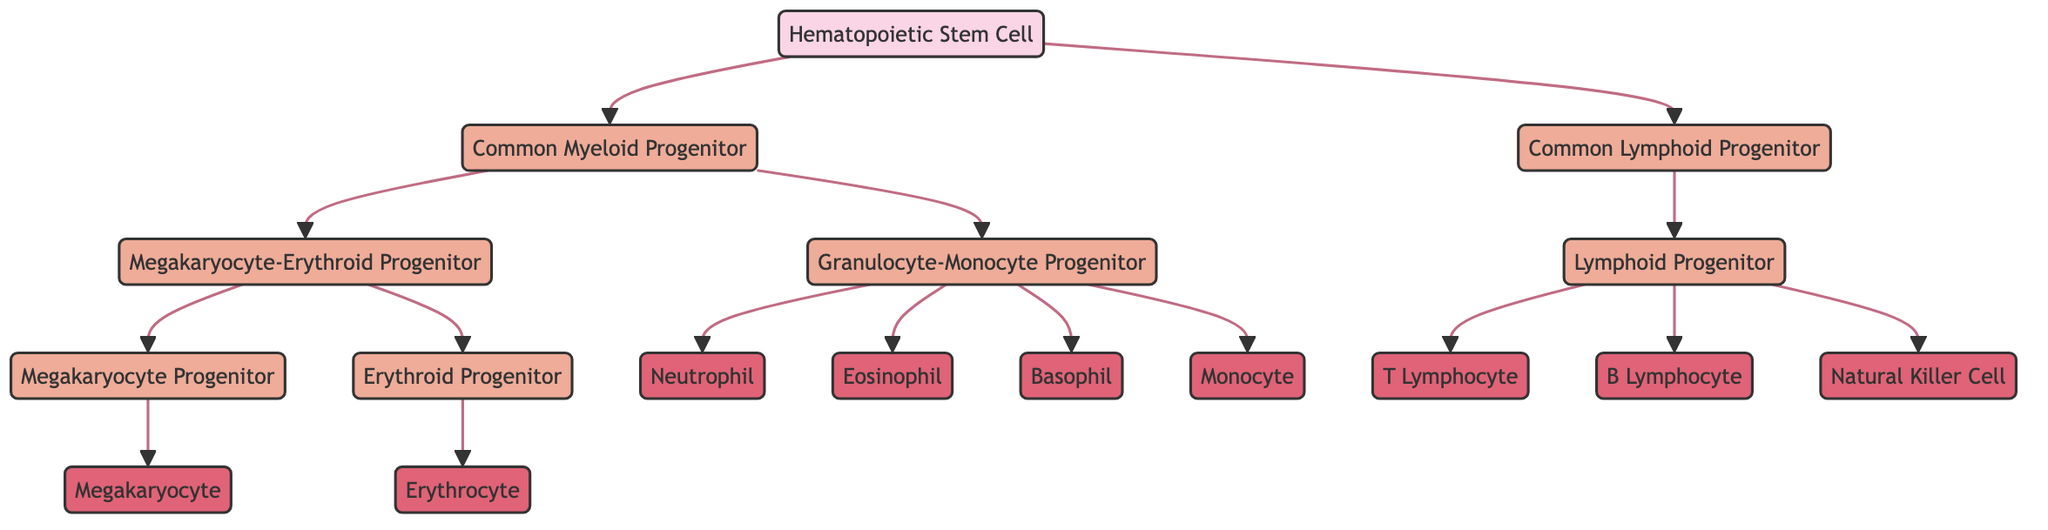What is the root node in this diagram? The root node, or the starting point of the hierarchy, is the Hematopoietic Stem Cell (HSC). It is visually positioned at the top of the diagram.
Answer: Hematopoietic Stem Cell How many mature blood cell types are shown in the diagram? By counting the mature cell types listed at the bottom of the diagram, the total comes to eight: Neutrophil, Eosinophil, Basophil, Monocyte, Megakaryocyte, Erythrocyte, T Lymphocyte, B Lymphocyte, and Natural Killer Cell.
Answer: 8 Which progenitor leads to Erythrocytes? Erythrocytes are derived from Erythroid Progenitor (EP) as indicated by the arrow pointing toward ERY from EP in the diagram.
Answer: Erythroid Progenitor How many types of progenitor cells are there in total? The diagram lists five types of progenitor cells: Common Myeloid Progenitor, Common Lymphoid Progenitor, Megakaryocyte-Erythroid Progenitor, Granulocyte-Monocyte Progenitor, and Lymphoid Progenitor, leading to a total of six types.
Answer: 6 Which cells are differentiated from the Granulocyte-Monocyte Progenitor? The Granulocyte-Monocyte Progenitor (GMP) differentiates into Neutrophils, Eosinophils, Basophils, and Monocytes, as shown by the corresponding arrows in the diagram.
Answer: Neutrophils, Eosinophils, Basophils, Monocytes Which cell type is produced from the Megakaryocyte Progenitor? The Megakaryocyte Progenitor (MKP) produces Megakaryocyte (MAG) as indicated by the direct link from MKP to MAG in the diagram.
Answer: Megakaryocyte What is the differentiation pathway from the Hematopoietic Stem Cell to the T Lymphocyte? Starting from the Hematopoietic Stem Cell (HSC), it differentiates into Common Lymphoid Progenitor (CLP), which then differentiates into Lymphoid Progenitor (LA), resulting in T Lymphocyte (T). The sequence is HSC to CLP to LA to T.
Answer: HSC → CLP → LA → T Identify the first step in blood cell differentiation depicted in the diagram. The first step is the differentiation of Hematopoietic Stem Cell (HSC) into two progenitor types: Common Myeloid Progenitor (CMP) and Common Lymphoid Progenitor (CLP). This is represented by the arrows branching from HSC.
Answer: Common Myeloid Progenitor, Common Lymphoid Progenitor 